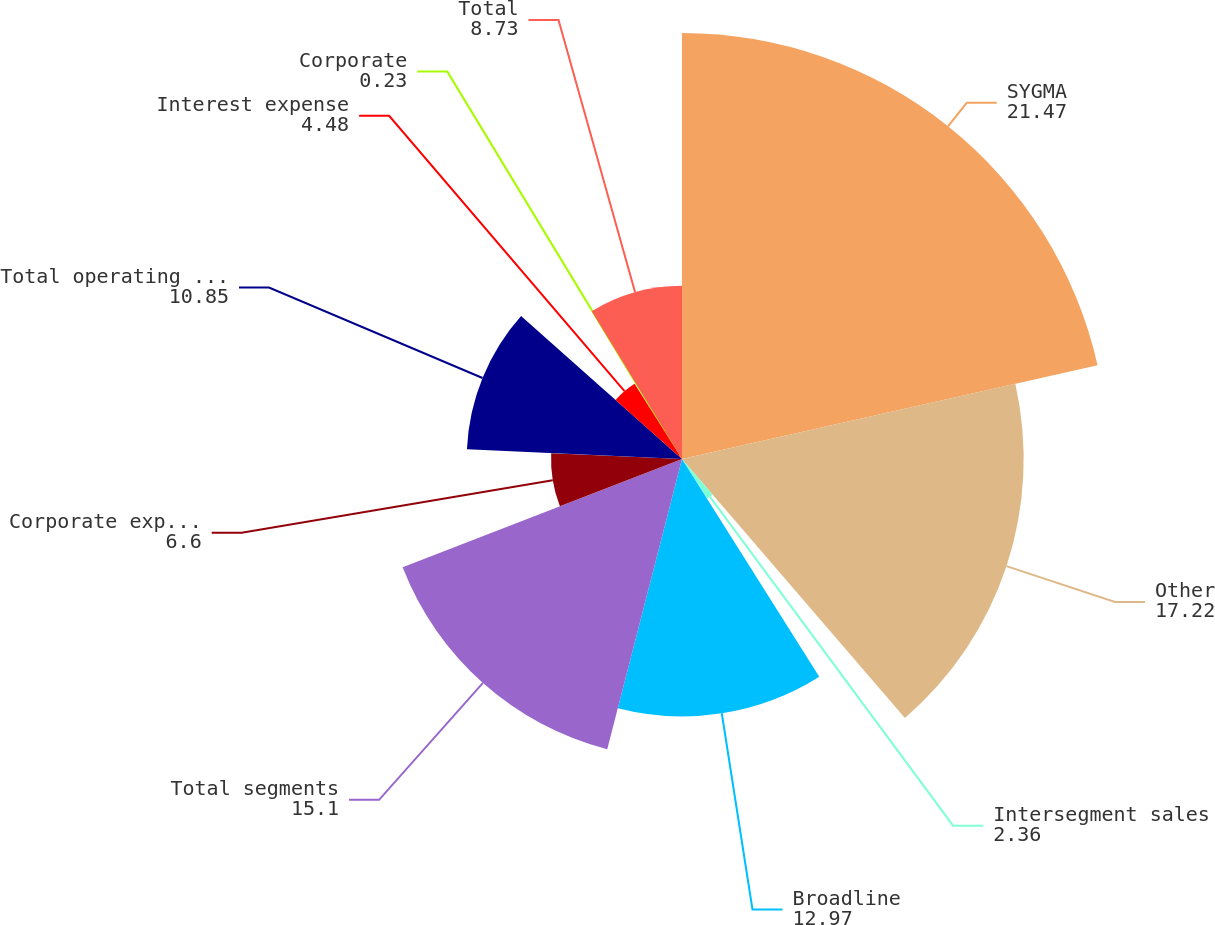Convert chart to OTSL. <chart><loc_0><loc_0><loc_500><loc_500><pie_chart><fcel>SYGMA<fcel>Other<fcel>Intersegment sales<fcel>Broadline<fcel>Total segments<fcel>Corporate expenses<fcel>Total operating income<fcel>Interest expense<fcel>Corporate<fcel>Total<nl><fcel>21.47%<fcel>17.22%<fcel>2.36%<fcel>12.97%<fcel>15.1%<fcel>6.6%<fcel>10.85%<fcel>4.48%<fcel>0.23%<fcel>8.73%<nl></chart> 